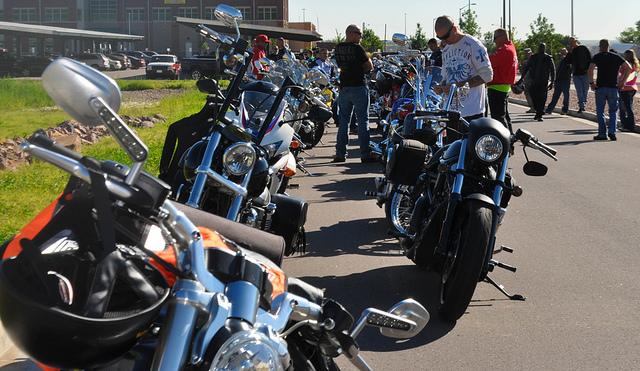Do these folks belong to a club?
Be succinct. Yes. What type of vehicle is shown in this picture?
Be succinct. Motorcycle. Where are the bikes parked?
Quick response, please. Street. 